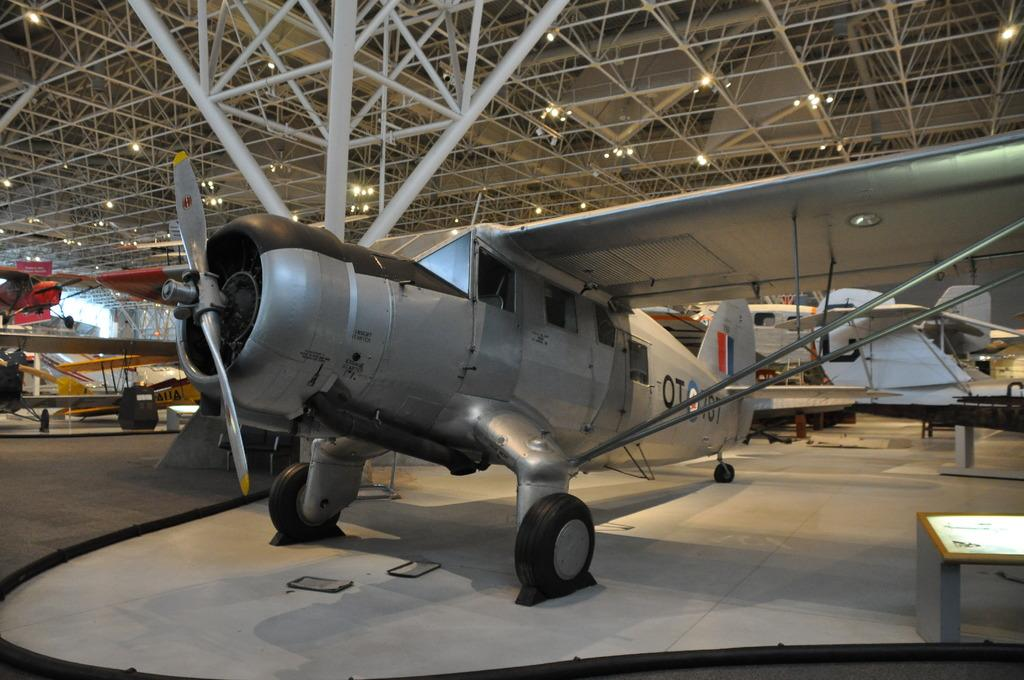What is the main subject of the image? The main subject of the image is an aeroplane. What color is the aeroplane? The aeroplane is grey in color. What else can be seen at the top of the image? There are lights visible at the top of the image. What type of structure is present in the image? It appears to be a shed in the image. What type of rod is being used to clean the orange in the image? There is no rod or orange present in the image. 